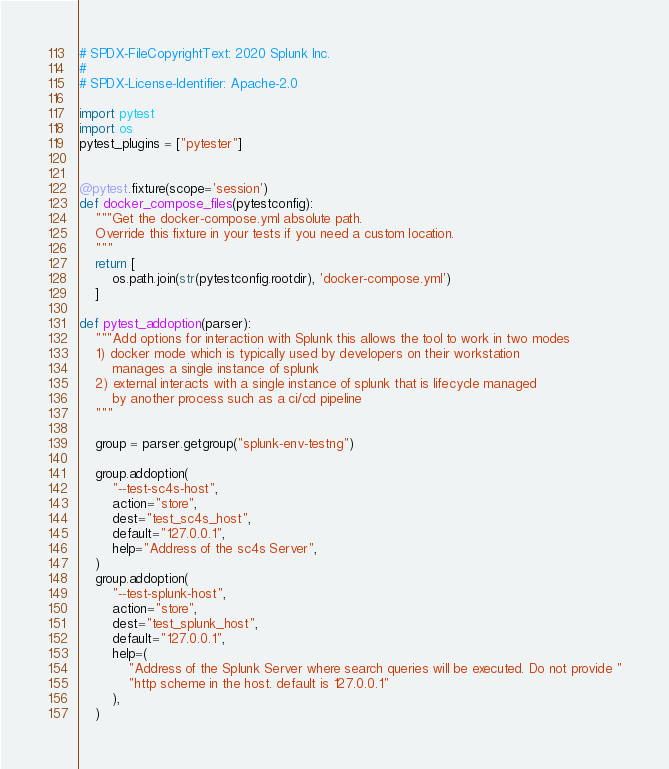Convert code to text. <code><loc_0><loc_0><loc_500><loc_500><_Python_># SPDX-FileCopyrightText: 2020 Splunk Inc.
#
# SPDX-License-Identifier: Apache-2.0

import pytest
import os
pytest_plugins = ["pytester"]


@pytest.fixture(scope='session')
def docker_compose_files(pytestconfig):
    """Get the docker-compose.yml absolute path.
    Override this fixture in your tests if you need a custom location.
    """
    return [
        os.path.join(str(pytestconfig.rootdir), 'docker-compose.yml')
    ]

def pytest_addoption(parser):
    """Add options for interaction with Splunk this allows the tool to work in two modes
    1) docker mode which is typically used by developers on their workstation
        manages a single instance of splunk
    2) external interacts with a single instance of splunk that is lifecycle managed
        by another process such as a ci/cd pipeline
    """

    group = parser.getgroup("splunk-env-testng")

    group.addoption(
        "--test-sc4s-host",
        action="store",
        dest="test_sc4s_host",
        default="127.0.0.1",
        help="Address of the sc4s Server",
    )
    group.addoption(
        "--test-splunk-host",
        action="store",
        dest="test_splunk_host",
        default="127.0.0.1",
        help=(
            "Address of the Splunk Server where search queries will be executed. Do not provide "
            "http scheme in the host. default is 127.0.0.1"
        ),
    )    </code> 